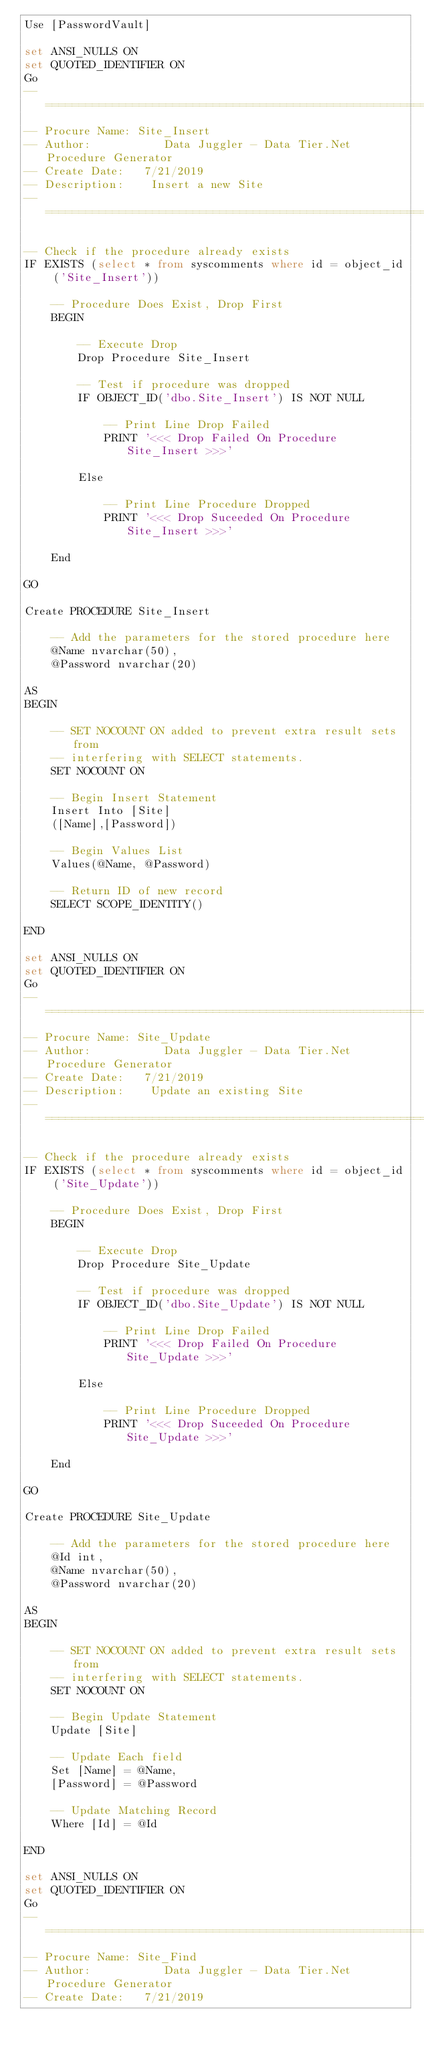<code> <loc_0><loc_0><loc_500><loc_500><_SQL_>Use [PasswordVault]

set ANSI_NULLS ON
set QUOTED_IDENTIFIER ON
Go
-- =========================================================
-- Procure Name: Site_Insert
-- Author:           Data Juggler - Data Tier.Net Procedure Generator
-- Create Date:   7/21/2019
-- Description:    Insert a new Site
-- =========================================================

-- Check if the procedure already exists
IF EXISTS (select * from syscomments where id = object_id ('Site_Insert'))

    -- Procedure Does Exist, Drop First
    BEGIN

        -- Execute Drop
        Drop Procedure Site_Insert

        -- Test if procedure was dropped
        IF OBJECT_ID('dbo.Site_Insert') IS NOT NULL

            -- Print Line Drop Failed
            PRINT '<<< Drop Failed On Procedure Site_Insert >>>'

        Else

            -- Print Line Procedure Dropped
            PRINT '<<< Drop Suceeded On Procedure Site_Insert >>>'

    End

GO

Create PROCEDURE Site_Insert

    -- Add the parameters for the stored procedure here
    @Name nvarchar(50),
    @Password nvarchar(20)

AS
BEGIN

    -- SET NOCOUNT ON added to prevent extra result sets from
    -- interfering with SELECT statements.
    SET NOCOUNT ON

    -- Begin Insert Statement
    Insert Into [Site]
    ([Name],[Password])

    -- Begin Values List
    Values(@Name, @Password)

    -- Return ID of new record
    SELECT SCOPE_IDENTITY()

END

set ANSI_NULLS ON
set QUOTED_IDENTIFIER ON
Go
-- =========================================================
-- Procure Name: Site_Update
-- Author:           Data Juggler - Data Tier.Net Procedure Generator
-- Create Date:   7/21/2019
-- Description:    Update an existing Site
-- =========================================================

-- Check if the procedure already exists
IF EXISTS (select * from syscomments where id = object_id ('Site_Update'))

    -- Procedure Does Exist, Drop First
    BEGIN

        -- Execute Drop
        Drop Procedure Site_Update

        -- Test if procedure was dropped
        IF OBJECT_ID('dbo.Site_Update') IS NOT NULL

            -- Print Line Drop Failed
            PRINT '<<< Drop Failed On Procedure Site_Update >>>'

        Else

            -- Print Line Procedure Dropped
            PRINT '<<< Drop Suceeded On Procedure Site_Update >>>'

    End

GO

Create PROCEDURE Site_Update

    -- Add the parameters for the stored procedure here
    @Id int,
    @Name nvarchar(50),
    @Password nvarchar(20)

AS
BEGIN

    -- SET NOCOUNT ON added to prevent extra result sets from
    -- interfering with SELECT statements.
    SET NOCOUNT ON

    -- Begin Update Statement
    Update [Site]

    -- Update Each field
    Set [Name] = @Name,
    [Password] = @Password

    -- Update Matching Record
    Where [Id] = @Id

END

set ANSI_NULLS ON
set QUOTED_IDENTIFIER ON
Go
-- =========================================================
-- Procure Name: Site_Find
-- Author:           Data Juggler - Data Tier.Net Procedure Generator
-- Create Date:   7/21/2019</code> 